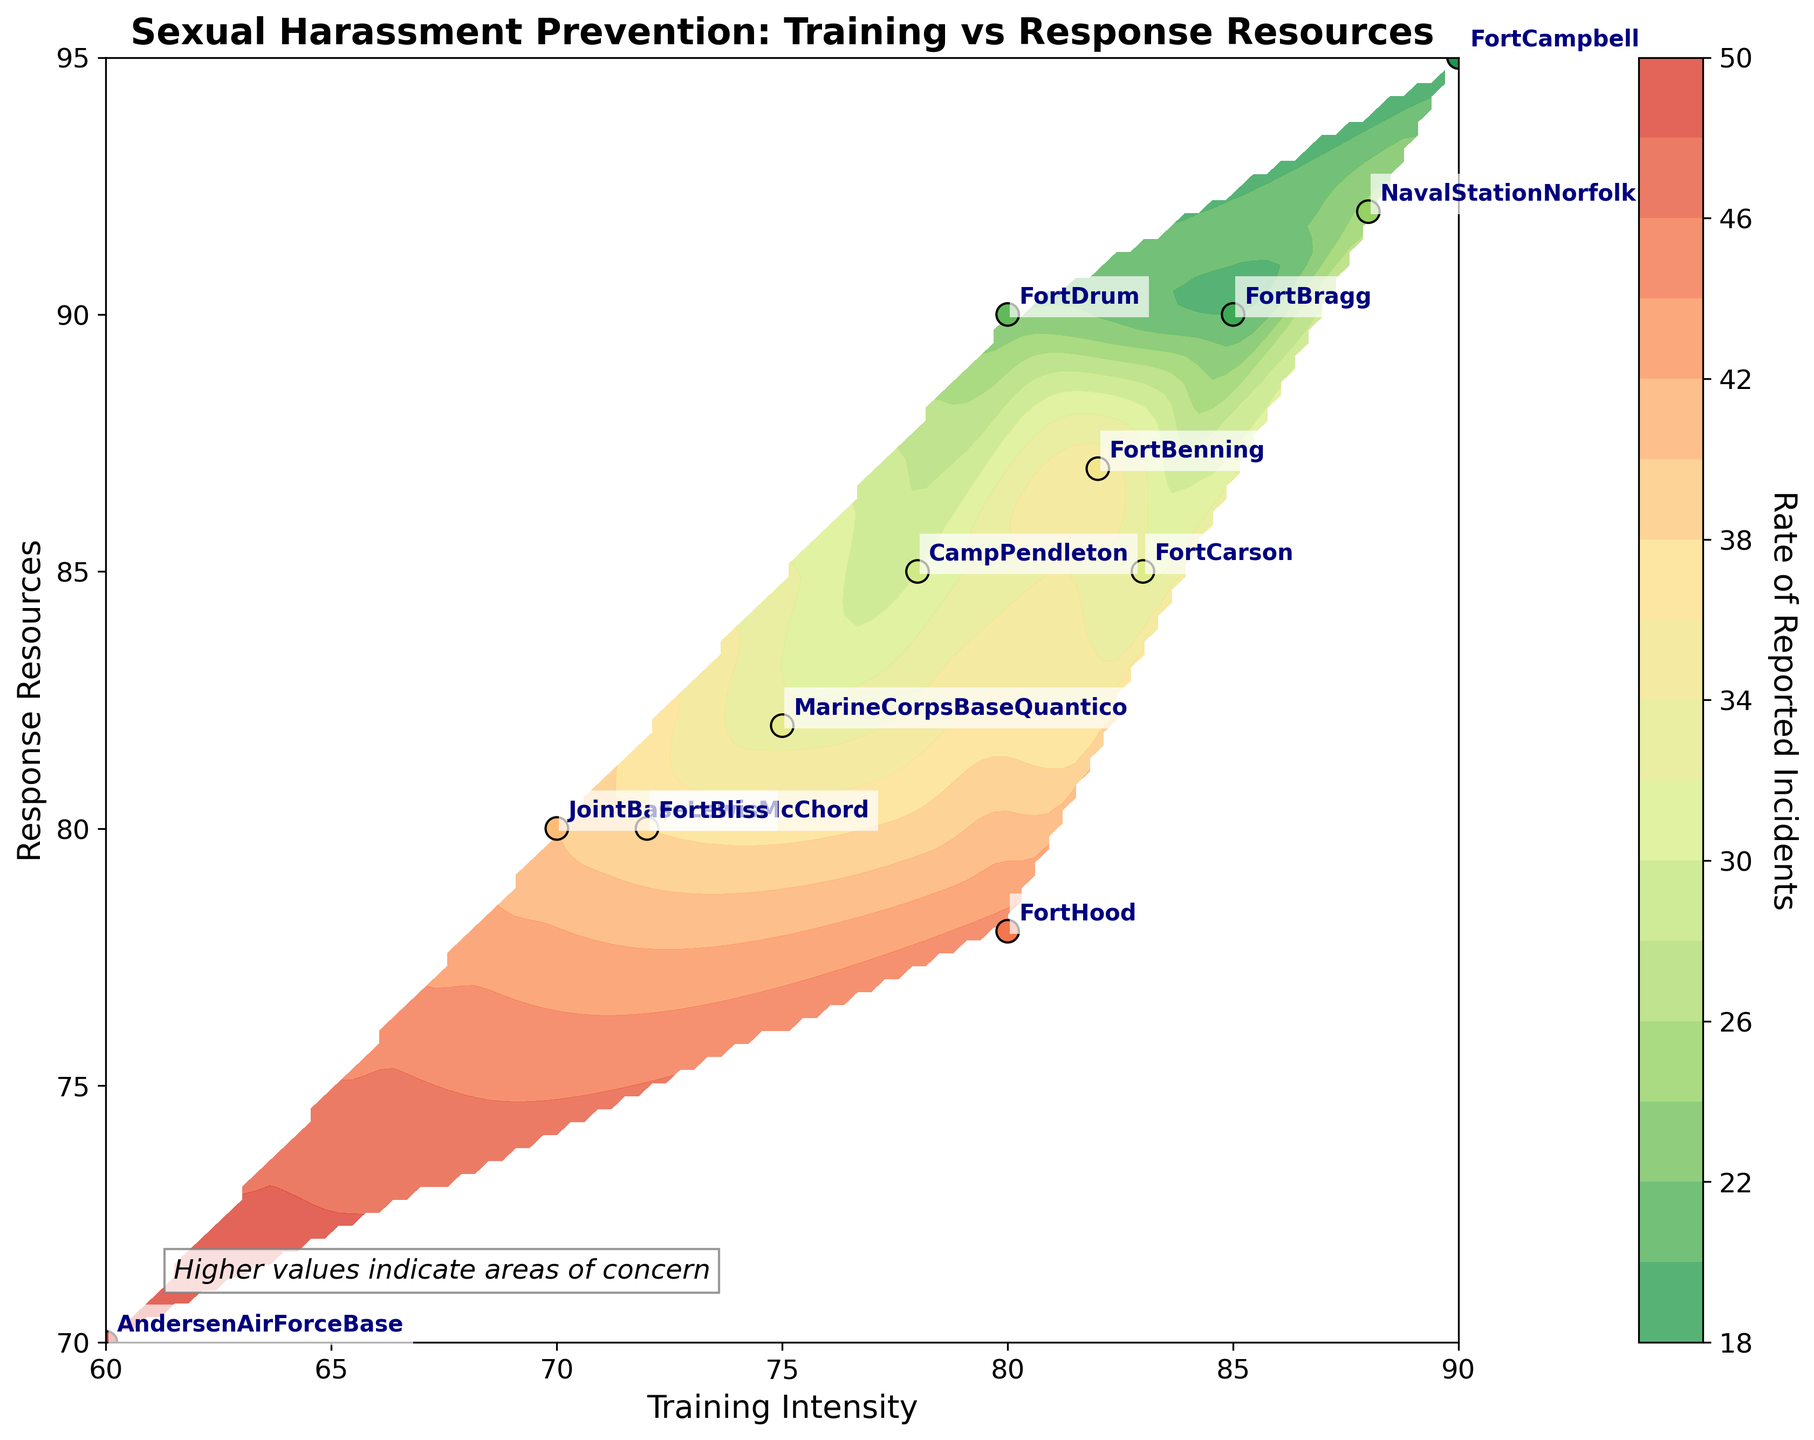How many installations are labeled in the plot? The figure shows text labels near data points for each military installation. Counting these specific labels gives us a total.
Answer: 12 What is the title of the plot? The title is usually located at the top of the plot. In this case, it reads, "Sexual Harassment Prevention: Training vs Response Resources."
Answer: Sexual Harassment Prevention: Training vs Response Resources Which installation has the highest training intensity? By examining the x-axis, which represents training intensity, we identify the data point farthest to the right and read its label.
Answer: Fort Campbell How does the rate of reported incidents vary with training intensity at high response resources? To answer this, look at the contour colors towards the upper right of the plot where response resources are high and training intensity is high. Check the color gradient to understand the rate of reported incidents in this zone.
Answer: Generally low Are there more installations with high training intensity or high response resources? Compare the distribution of data points along the x-axis and y-axis to determine which axis has more data points concentrated in the higher value range.
Answer: High response resources Which location has the lowest rate of reported incidents? Check the color coding of the scatter points and find the point with the darkest shade of green (indicating the lowest rate).
Answer: Fort Campbell What is the general trend between training intensity and response resources regarding reported incident rates? Look at the color gradients of the contours from lower left to upper right of the plot. Notice if the reported incidents increase or decrease as training intensity and response resources increase.
Answer: Decrease How many data points have a training intensity above 80? Examine the x-axis and count the number of data points to the right of the value 80.
Answer: 6 Is there any installation with low training intensity but high response resources? Check the lower range of the x-axis (training intensity) and the higher range of the y-axis (response resources) for any data points within this region.
Answer: No Which installations have a rate of reported incidents between 20 and 30? Identify the data points by their color and cross-reference with their labels, ensuring the colors fall within the rate of 20 to 30 as indicated by the color bar.
Answer: Fort Bragg, Naval Station Norfolk 